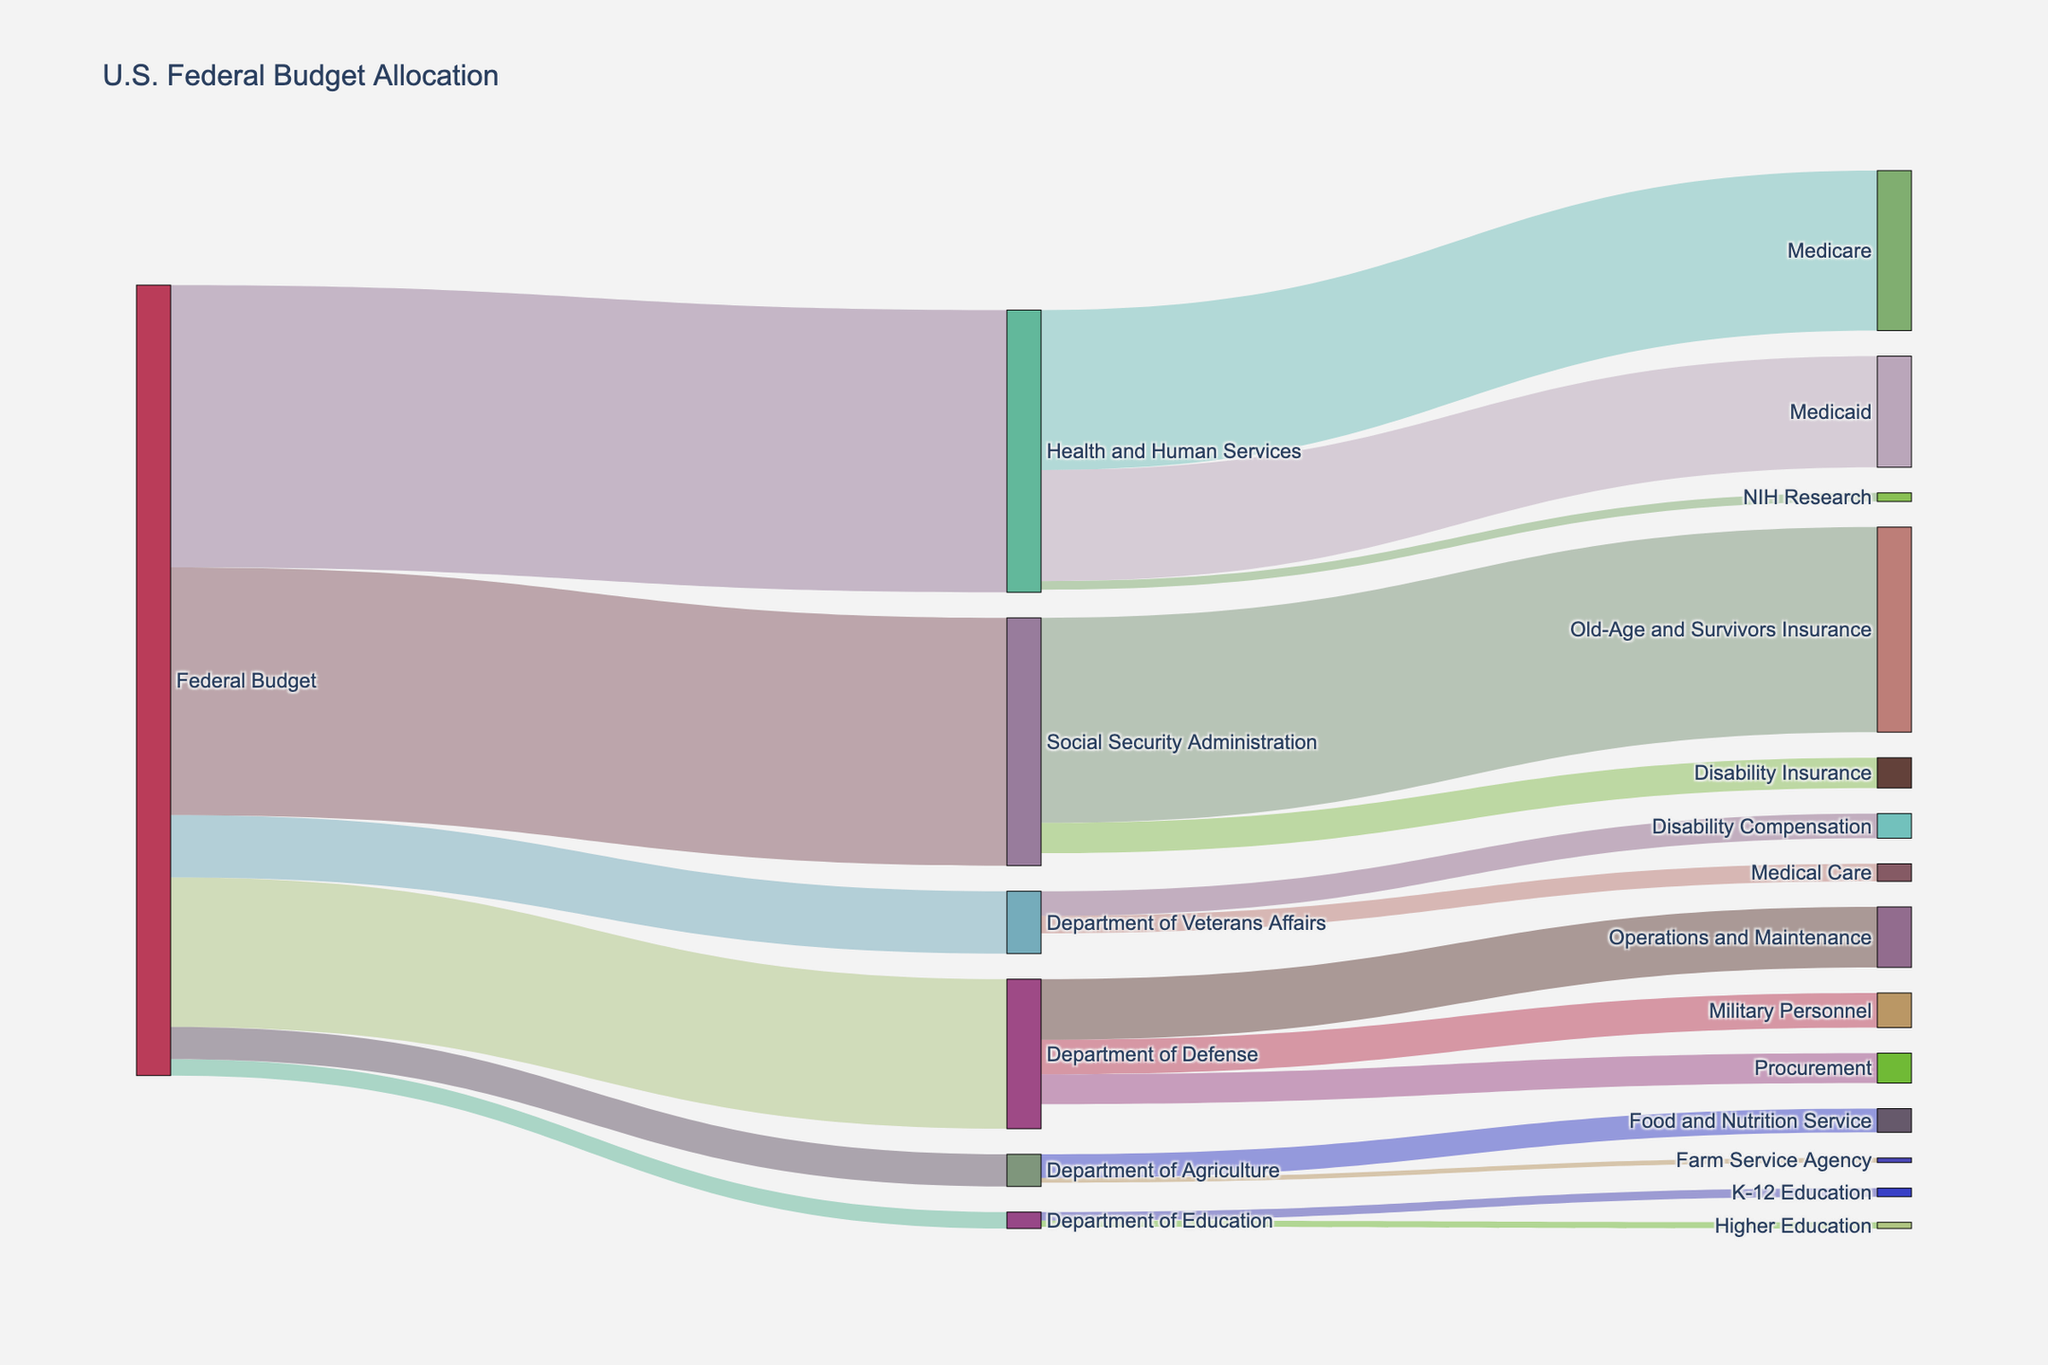what is the title of the figure? The title of the figure is usually displayed at the top of the Sankey diagram. In this case, the title text provided in the code is "U.S. Federal Budget Allocation."
Answer: U.S. Federal Budget Allocation Which department receives the highest allocation from the federal budget? By examining the flow from the "Federal Budget" node to various departments, the width of the links or the values can be compared. Health and Human Services has the highest value at 1362.0.
Answer: Health and Human Services How much is allocated to the Department of Education? To determine this, look at the value of the link between the "Federal Budget" and the "Department of Education." From the data, this value is 79.2.
Answer: 79.2 What departments receive funding from the federal budget? From the "Federal Budget" node, follow the links to the departments. They are: Department of Defense, Health and Human Services, Social Security Administration, Department of Education, Department of Veterans Affairs, and Department of Agriculture.
Answer: Department of Defense, Health and Human Services, Social Security Administration, Department of Education, Department of Veterans Affairs, Department of Agriculture What is the allocation for Medicare under Health and Human Services? Locate the link between the "Health and Human Services" node and the "Medicare" node. The corresponding value is 772.1.
Answer: 772.1 Which program within the Department of Defense receives the second-highest funding? Look at the allocations within the Department of Defense: Military Personnel (166.8), Operations and Maintenance (291.9), and Procurement (144.3). The second-highest is Military Personnel with 166.8.
Answer: Military Personnel What is the total allocation for Social Security Administration? Sum the allocations from Social Security Administration to its relevant programs: Old-Age and Survivors Insurance (989.5) and Disability Insurance (146.3). The total is 989.5 + 146.3 = 1135.8.
Answer: 1135.8 Which receives more funding, Medicaid under Health and Human Services or Disability Insurance under Social Security Administration? Compare the values: Medicaid has 536.2, and Disability Insurance has 146.3. Medicaid receives more funding.
Answer: Medicaid What percentage of the federal budget is allocated to the Department of Veterans Affairs? The total federal budget allocation sum is 721.5 (Department of Defense) + 1362.0 (HHS) + 1196.0 (SSA) + 79.2 (DOE) + 301.0 (DVA) + 155.4 (Agriculture) = 3815.1. The Department of Veterans Affairs receives 301.0. The percentage is (301.0 / 3815.1) * 100 ≈ 7.89%.
Answer: 7.89% Within the Department of Agriculture, which program receives the least funding, and how much is it? Examine the allocations within the Department of Agriculture: Food and Nutrition Service (114.2) and Farm Service Agency (22.6). The Farm Service Agency receives the least funding with 22.6.
Answer: Farm Service Agency, 22.6 